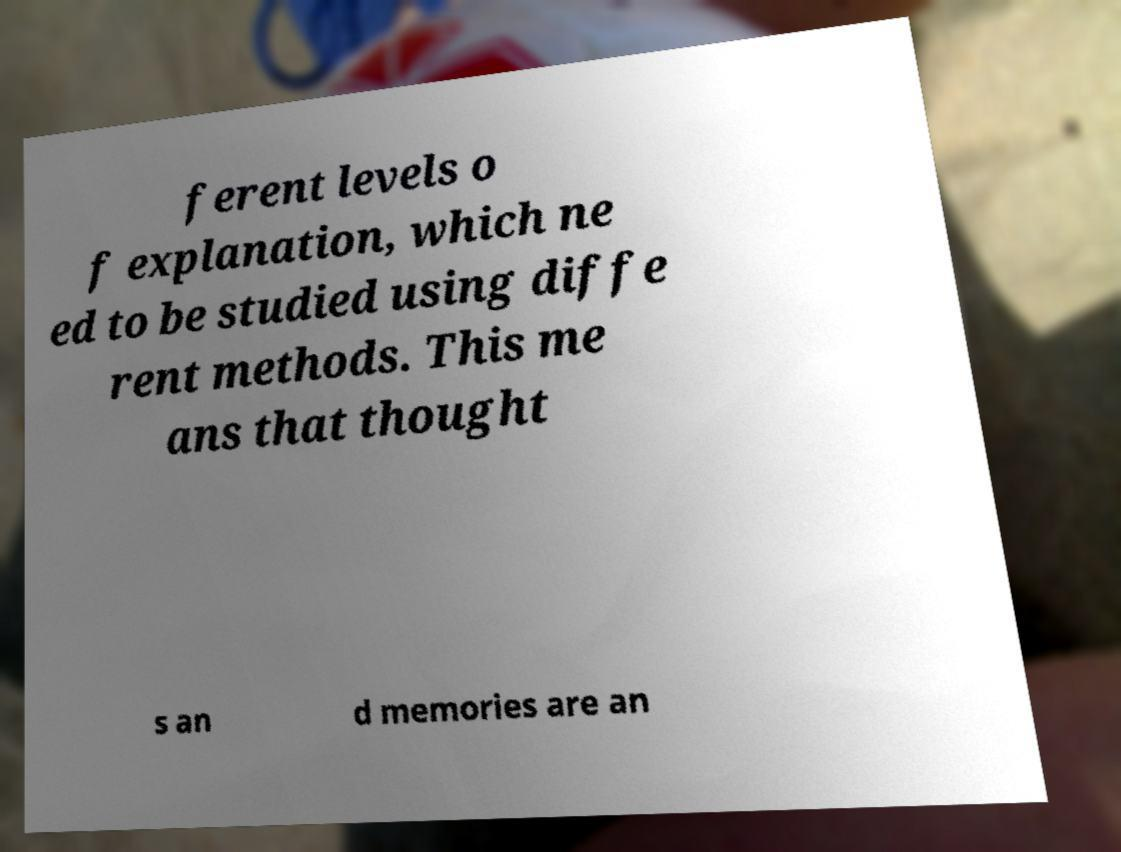For documentation purposes, I need the text within this image transcribed. Could you provide that? ferent levels o f explanation, which ne ed to be studied using diffe rent methods. This me ans that thought s an d memories are an 